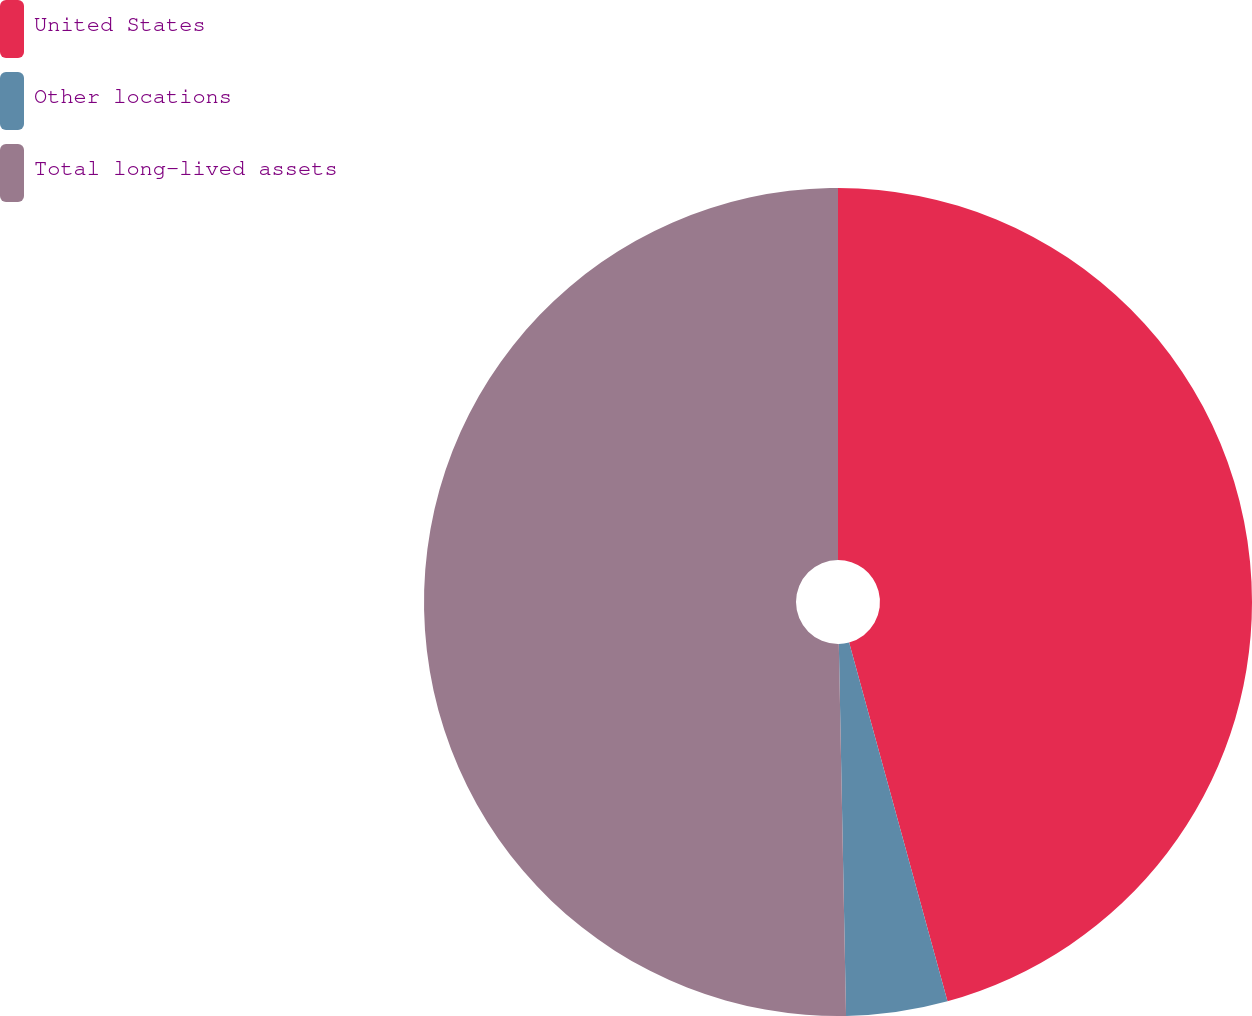Convert chart. <chart><loc_0><loc_0><loc_500><loc_500><pie_chart><fcel>United States<fcel>Other locations<fcel>Total long-lived assets<nl><fcel>45.74%<fcel>3.95%<fcel>50.31%<nl></chart> 